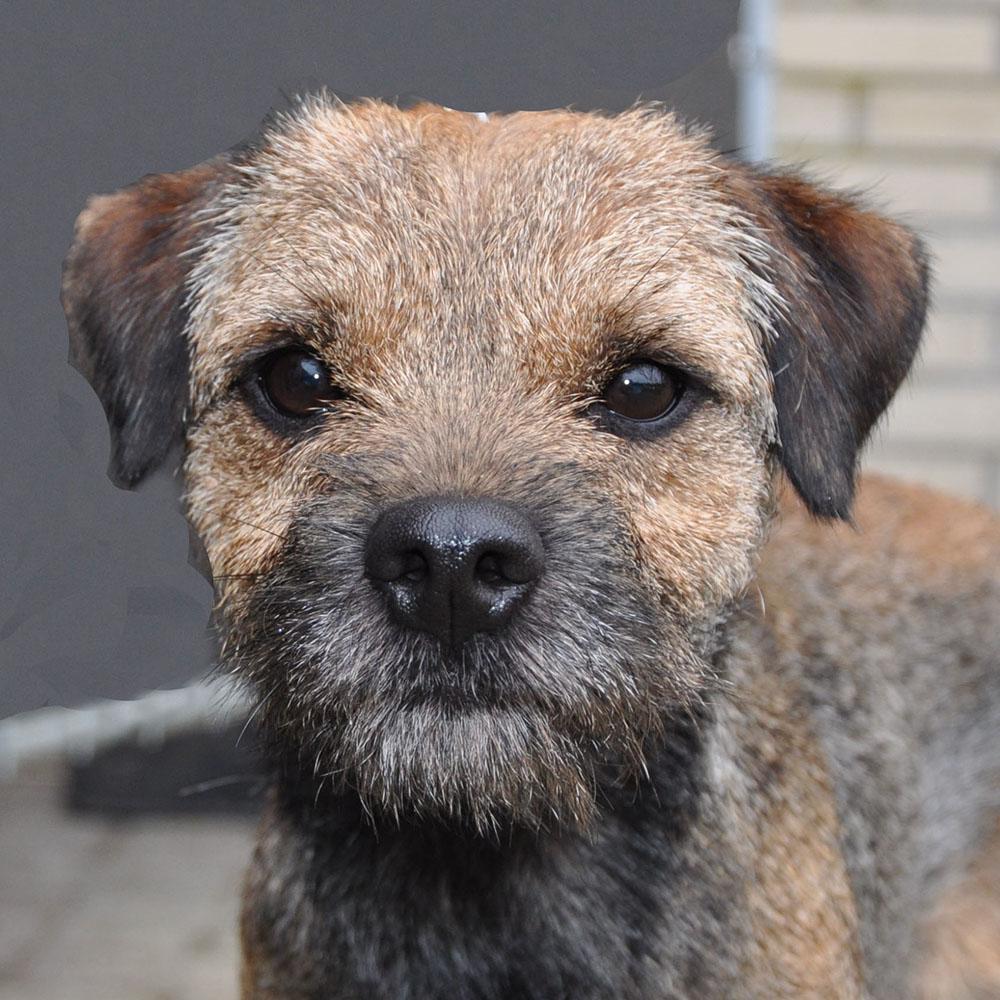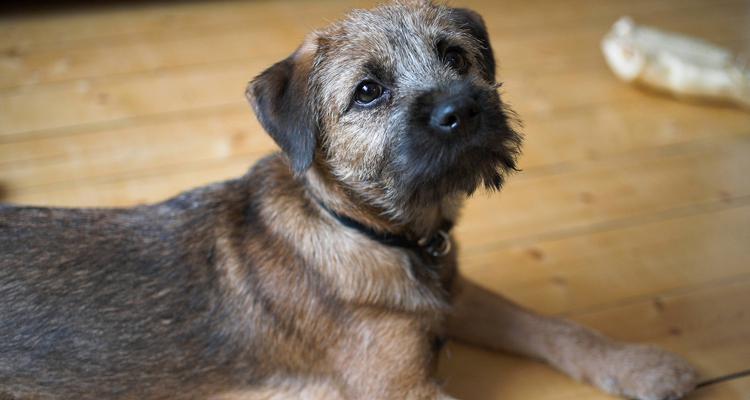The first image is the image on the left, the second image is the image on the right. Given the left and right images, does the statement "A collar is visible around the neck of the dog in the right image." hold true? Answer yes or no. Yes. 